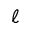<formula> <loc_0><loc_0><loc_500><loc_500>\ell</formula> 